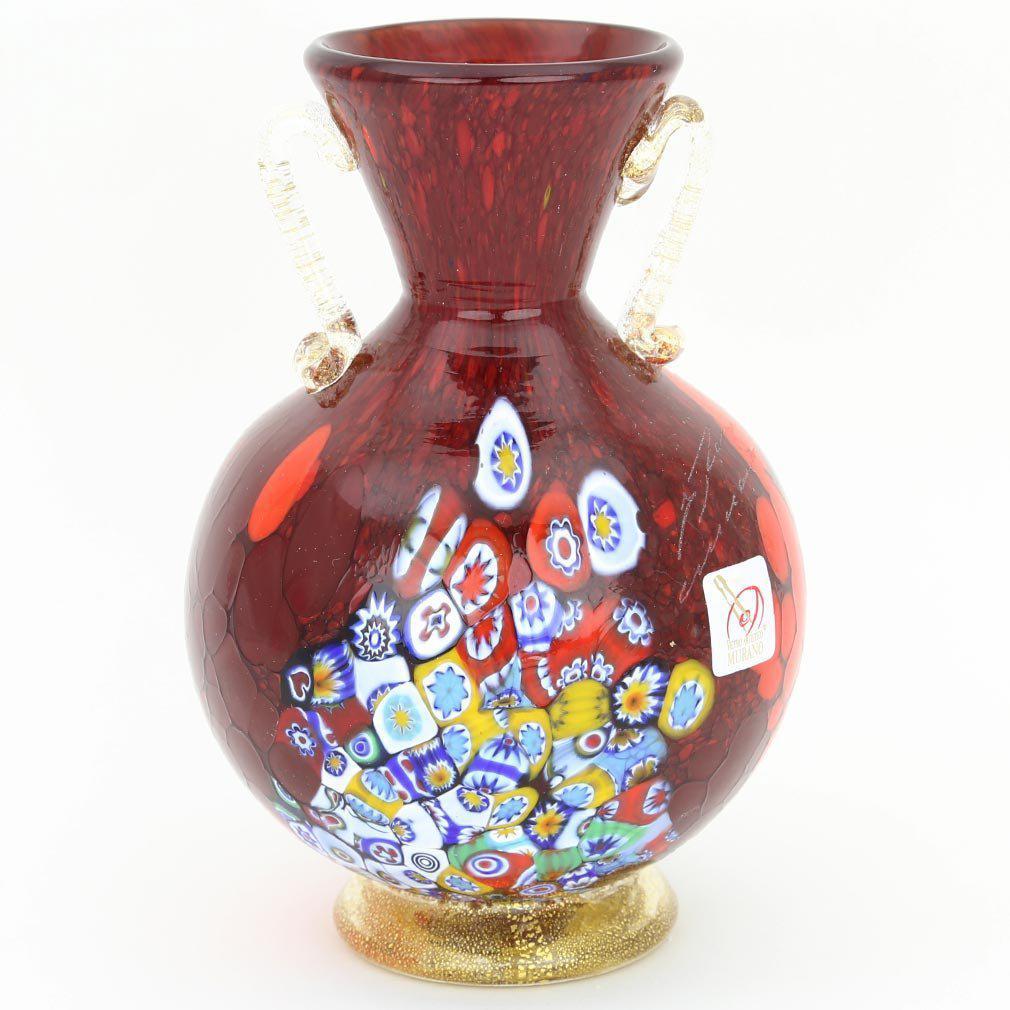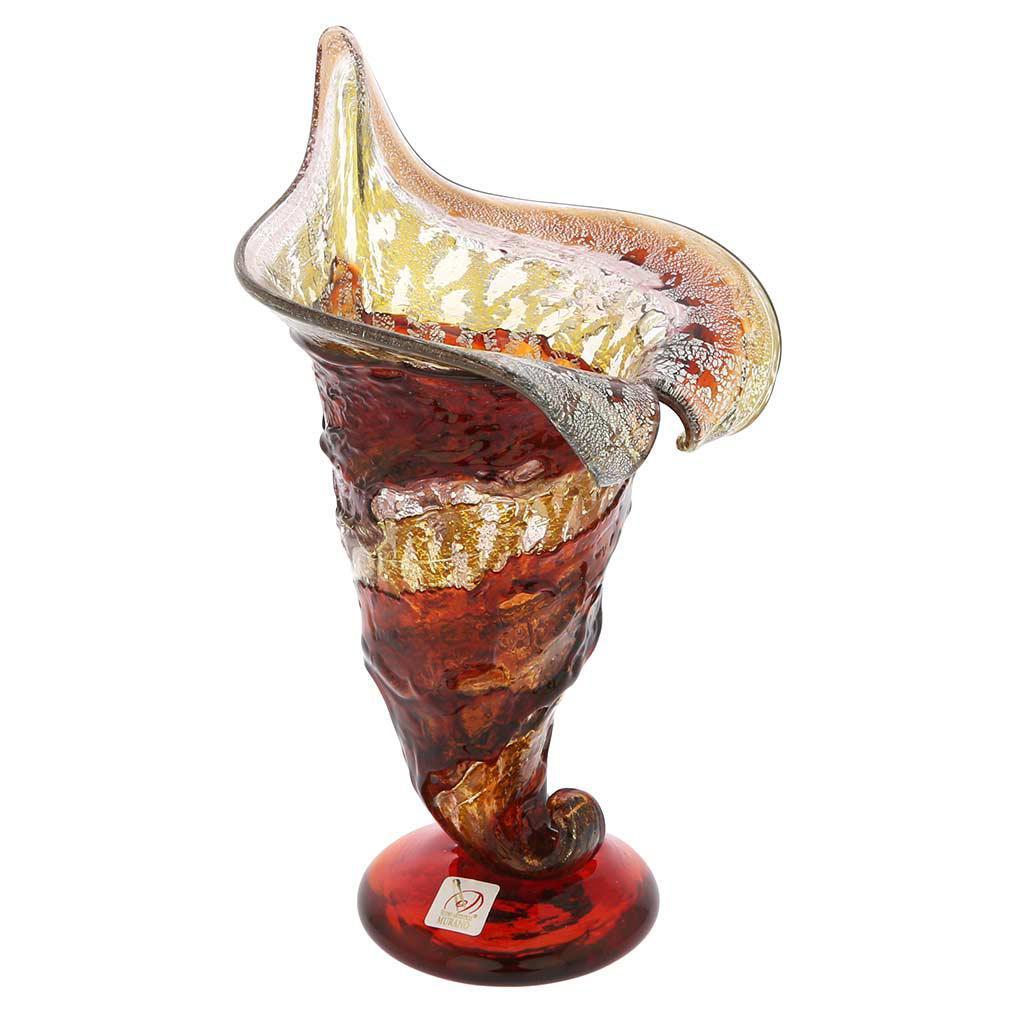The first image is the image on the left, the second image is the image on the right. Analyze the images presented: Is the assertion "The vase in the right image is bluish-green, with no other bright colors on it." valid? Answer yes or no. No. The first image is the image on the left, the second image is the image on the right. Examine the images to the left and right. Is the description "The vase on the right is a green color." accurate? Answer yes or no. No. 